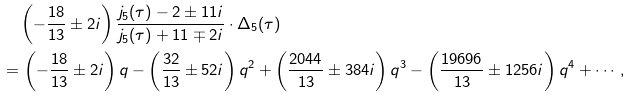Convert formula to latex. <formula><loc_0><loc_0><loc_500><loc_500>& \quad \left ( - \frac { 1 8 } { 1 3 } \pm 2 i \right ) \frac { j _ { 5 } ( \tau ) - 2 \pm 1 1 i } { j _ { 5 } ( \tau ) + 1 1 \mp 2 i } \cdot \Delta _ { 5 } ( \tau ) \\ & = \left ( - \frac { 1 8 } { 1 3 } \pm 2 i \right ) q - \left ( \frac { 3 2 } { 1 3 } \pm 5 2 i \right ) q ^ { 2 } + \left ( \frac { 2 0 4 4 } { 1 3 } \pm 3 8 4 i \right ) q ^ { 3 } - \left ( \frac { 1 9 6 9 6 } { 1 3 } \pm 1 2 5 6 i \right ) q ^ { 4 } + \cdots ,</formula> 